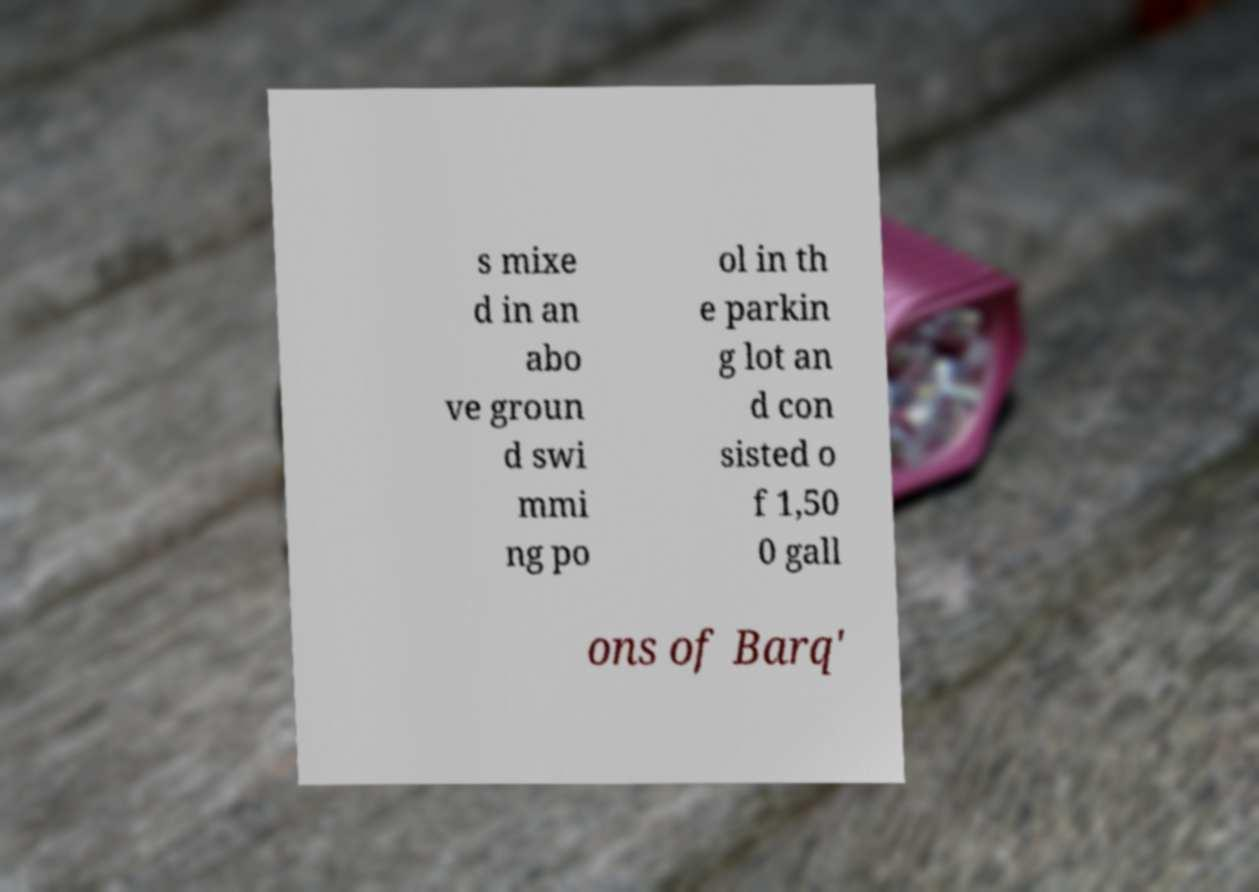Can you read and provide the text displayed in the image?This photo seems to have some interesting text. Can you extract and type it out for me? s mixe d in an abo ve groun d swi mmi ng po ol in th e parkin g lot an d con sisted o f 1,50 0 gall ons of Barq' 